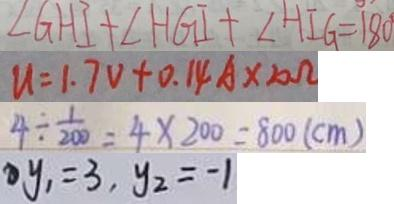<formula> <loc_0><loc_0><loc_500><loc_500>\angle G H I + \angle H G I + \angle H I G = 1 8 0 ^ { \circ } 
 u = 1 . 7 V + 0 . 1 4 A \times 2 0 \Omega 
 4 \div \frac { 1 } { 2 0 0 } = 4 \times 2 0 0 = 8 0 0 ( c m ) 
 y _ { 1 } = 3 , y _ { 2 } = - 1</formula> 